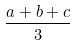<formula> <loc_0><loc_0><loc_500><loc_500>\frac { a + b + c } { 3 }</formula> 